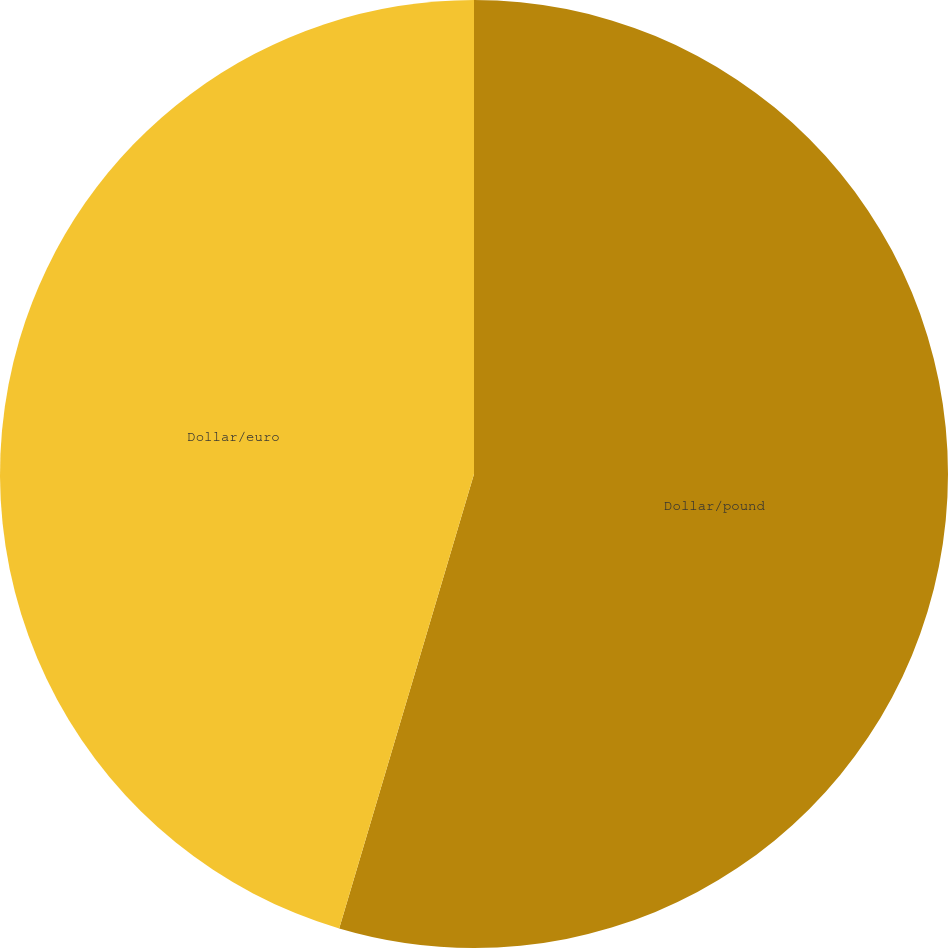Convert chart. <chart><loc_0><loc_0><loc_500><loc_500><pie_chart><fcel>Dollar/pound<fcel>Dollar/euro<nl><fcel>54.59%<fcel>45.41%<nl></chart> 